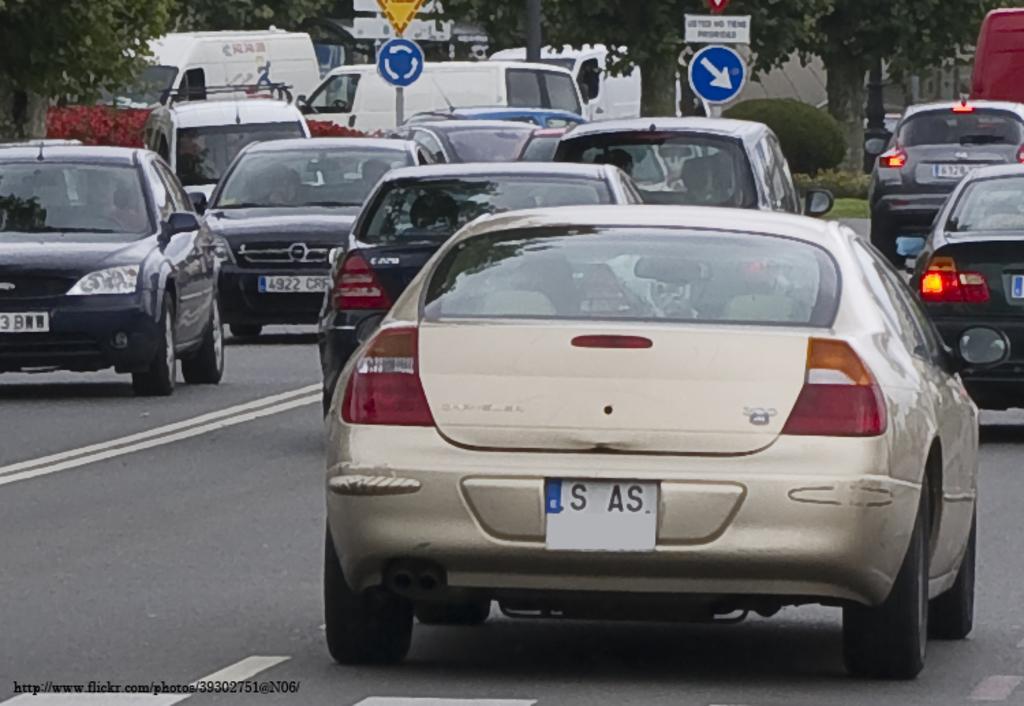How would you summarize this image in a sentence or two? In this image we can see few persons are riding vehicles on the road, sign boards on the poles, trees, plants and objects. 